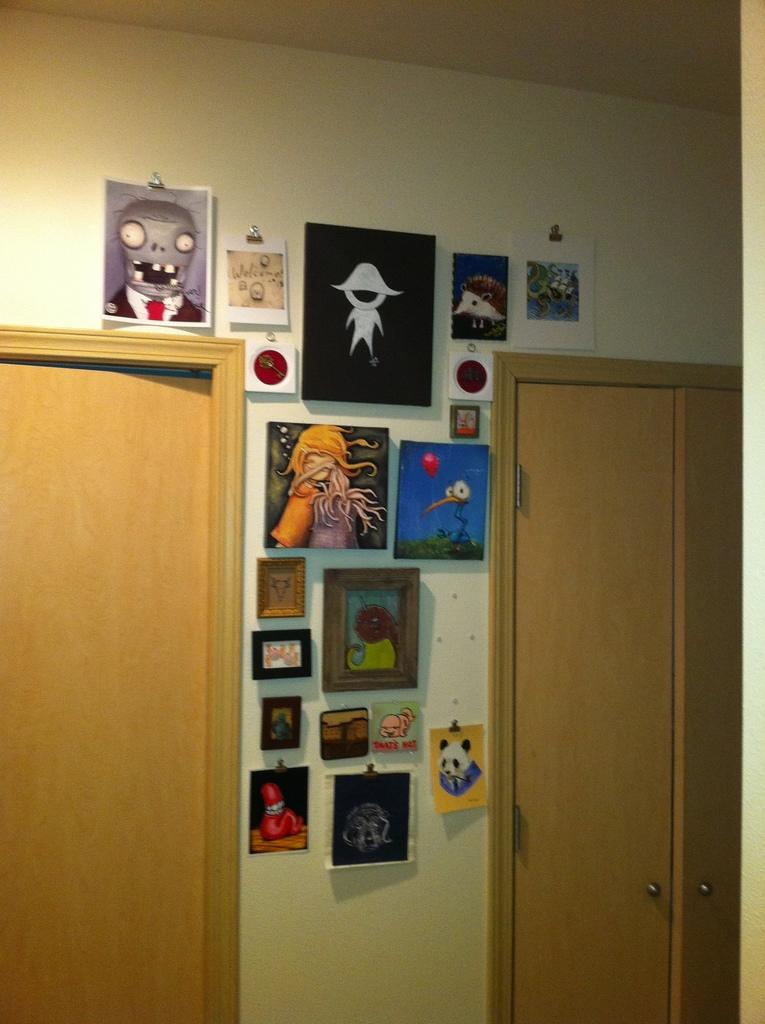What type of space is shown in the image? The image is an inside view of a room. Are there any doors visible in the room? Yes, there are doors on the right and left sides of the image. What can be seen on the wall between the doors? Frames and posters are attached to the wall between the doors. Can you see any beans growing on the wall in the image? There are no beans visible in the image; it shows a room with doors and frames on the wall. Is there a rock formation in the middle of the room in the image? There is no rock formation present in the image; it is an inside view of a room with doors and frames on the wall. 